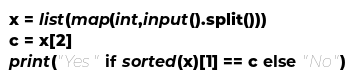Convert code to text. <code><loc_0><loc_0><loc_500><loc_500><_Python_>x = list(map(int,input().split()))
c = x[2]
print("Yes" if sorted(x)[1] == c else "No")</code> 